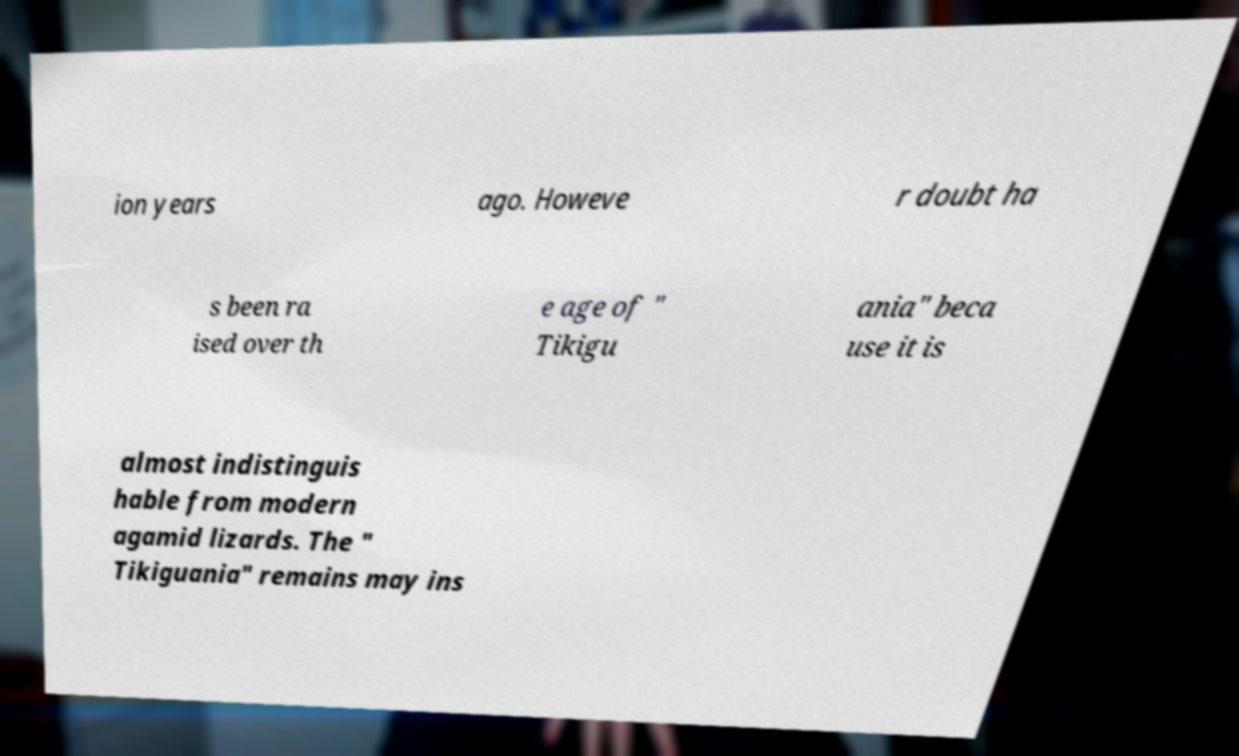Can you accurately transcribe the text from the provided image for me? ion years ago. Howeve r doubt ha s been ra ised over th e age of " Tikigu ania" beca use it is almost indistinguis hable from modern agamid lizards. The " Tikiguania" remains may ins 